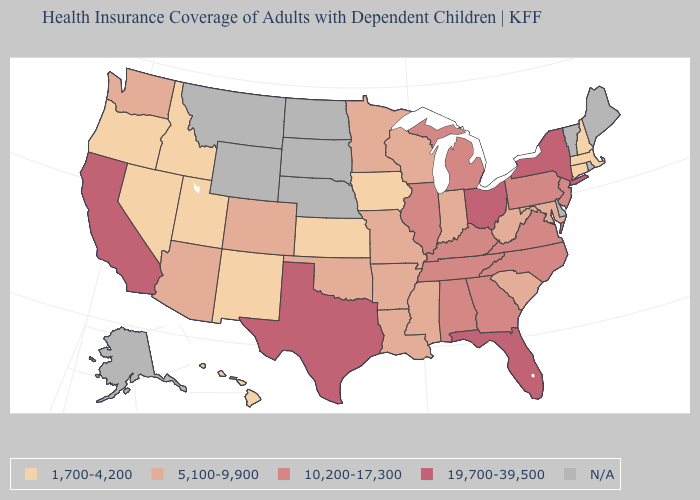Which states have the lowest value in the USA?
Concise answer only. Connecticut, Hawaii, Idaho, Iowa, Kansas, Massachusetts, Nevada, New Hampshire, New Mexico, Oregon, Utah. What is the lowest value in the West?
Keep it brief. 1,700-4,200. What is the highest value in the MidWest ?
Be succinct. 19,700-39,500. What is the value of West Virginia?
Write a very short answer. 5,100-9,900. Which states have the lowest value in the USA?
Quick response, please. Connecticut, Hawaii, Idaho, Iowa, Kansas, Massachusetts, Nevada, New Hampshire, New Mexico, Oregon, Utah. What is the value of Connecticut?
Write a very short answer. 1,700-4,200. Which states hav the highest value in the South?
Answer briefly. Florida, Texas. Among the states that border Nebraska , does Kansas have the highest value?
Write a very short answer. No. What is the highest value in states that border Kentucky?
Give a very brief answer. 19,700-39,500. Name the states that have a value in the range 1,700-4,200?
Give a very brief answer. Connecticut, Hawaii, Idaho, Iowa, Kansas, Massachusetts, Nevada, New Hampshire, New Mexico, Oregon, Utah. What is the lowest value in states that border Georgia?
Concise answer only. 5,100-9,900. Among the states that border Michigan , does Ohio have the highest value?
Give a very brief answer. Yes. Name the states that have a value in the range 5,100-9,900?
Give a very brief answer. Arizona, Arkansas, Colorado, Indiana, Louisiana, Maryland, Minnesota, Mississippi, Missouri, Oklahoma, South Carolina, Washington, West Virginia, Wisconsin. Name the states that have a value in the range 19,700-39,500?
Be succinct. California, Florida, New York, Ohio, Texas. 